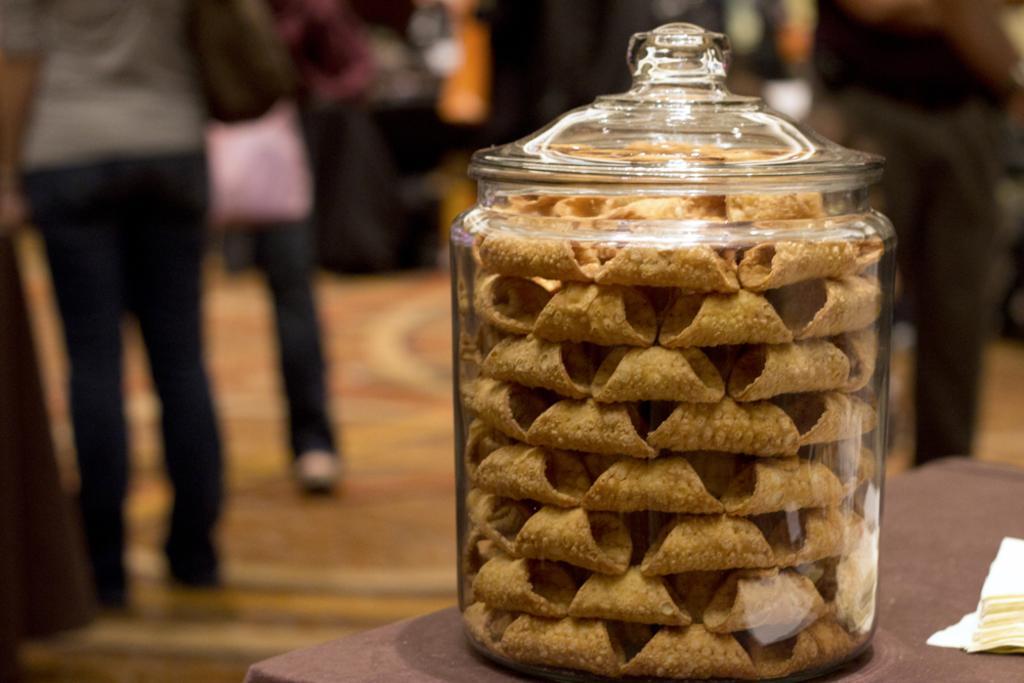In one or two sentences, can you explain what this image depicts? In this image, There is a table on that table there is a glass jar, In that glass jar there is some food items,in the background there are some people standing and there is a floor in yellow color. 